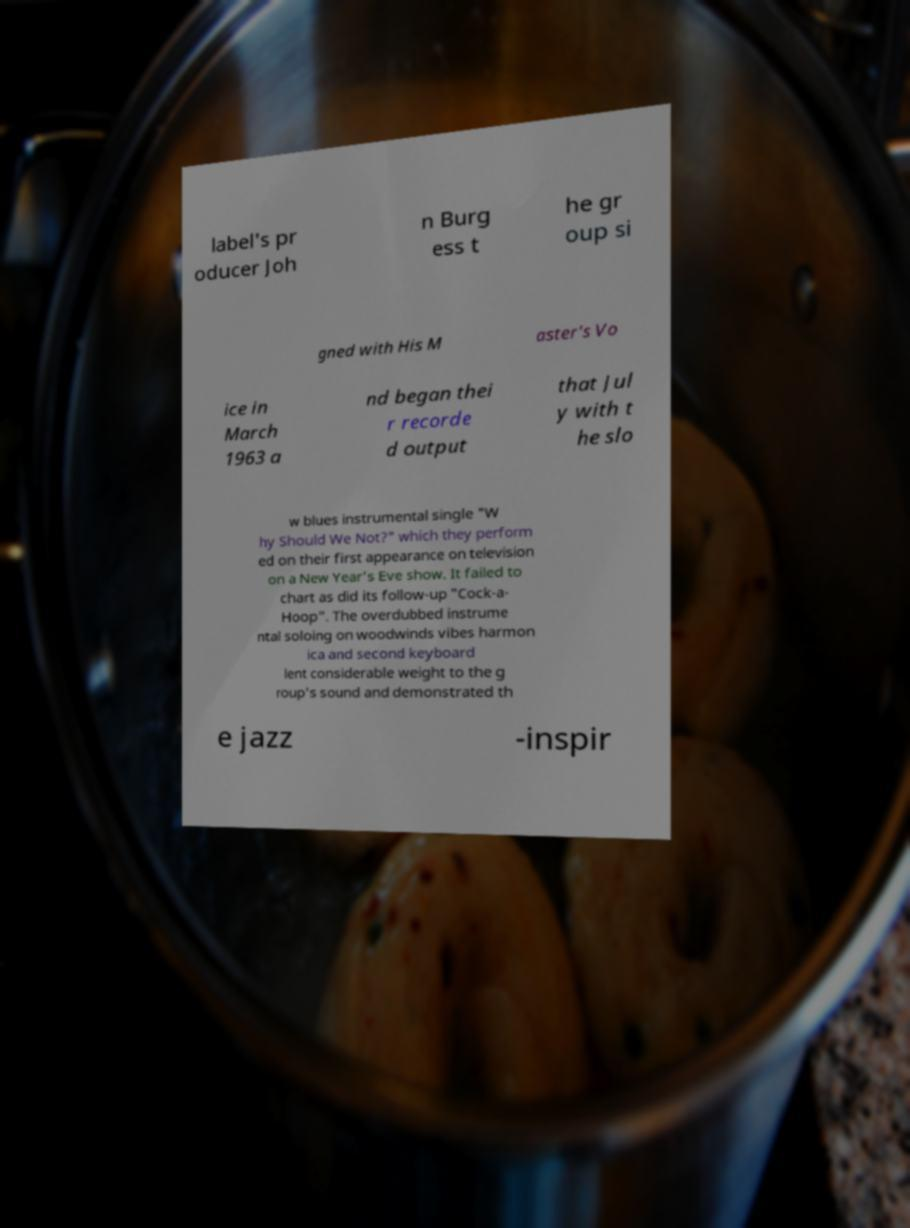For documentation purposes, I need the text within this image transcribed. Could you provide that? label's pr oducer Joh n Burg ess t he gr oup si gned with His M aster's Vo ice in March 1963 a nd began thei r recorde d output that Jul y with t he slo w blues instrumental single "W hy Should We Not?" which they perform ed on their first appearance on television on a New Year's Eve show. It failed to chart as did its follow-up "Cock-a- Hoop". The overdubbed instrume ntal soloing on woodwinds vibes harmon ica and second keyboard lent considerable weight to the g roup's sound and demonstrated th e jazz -inspir 